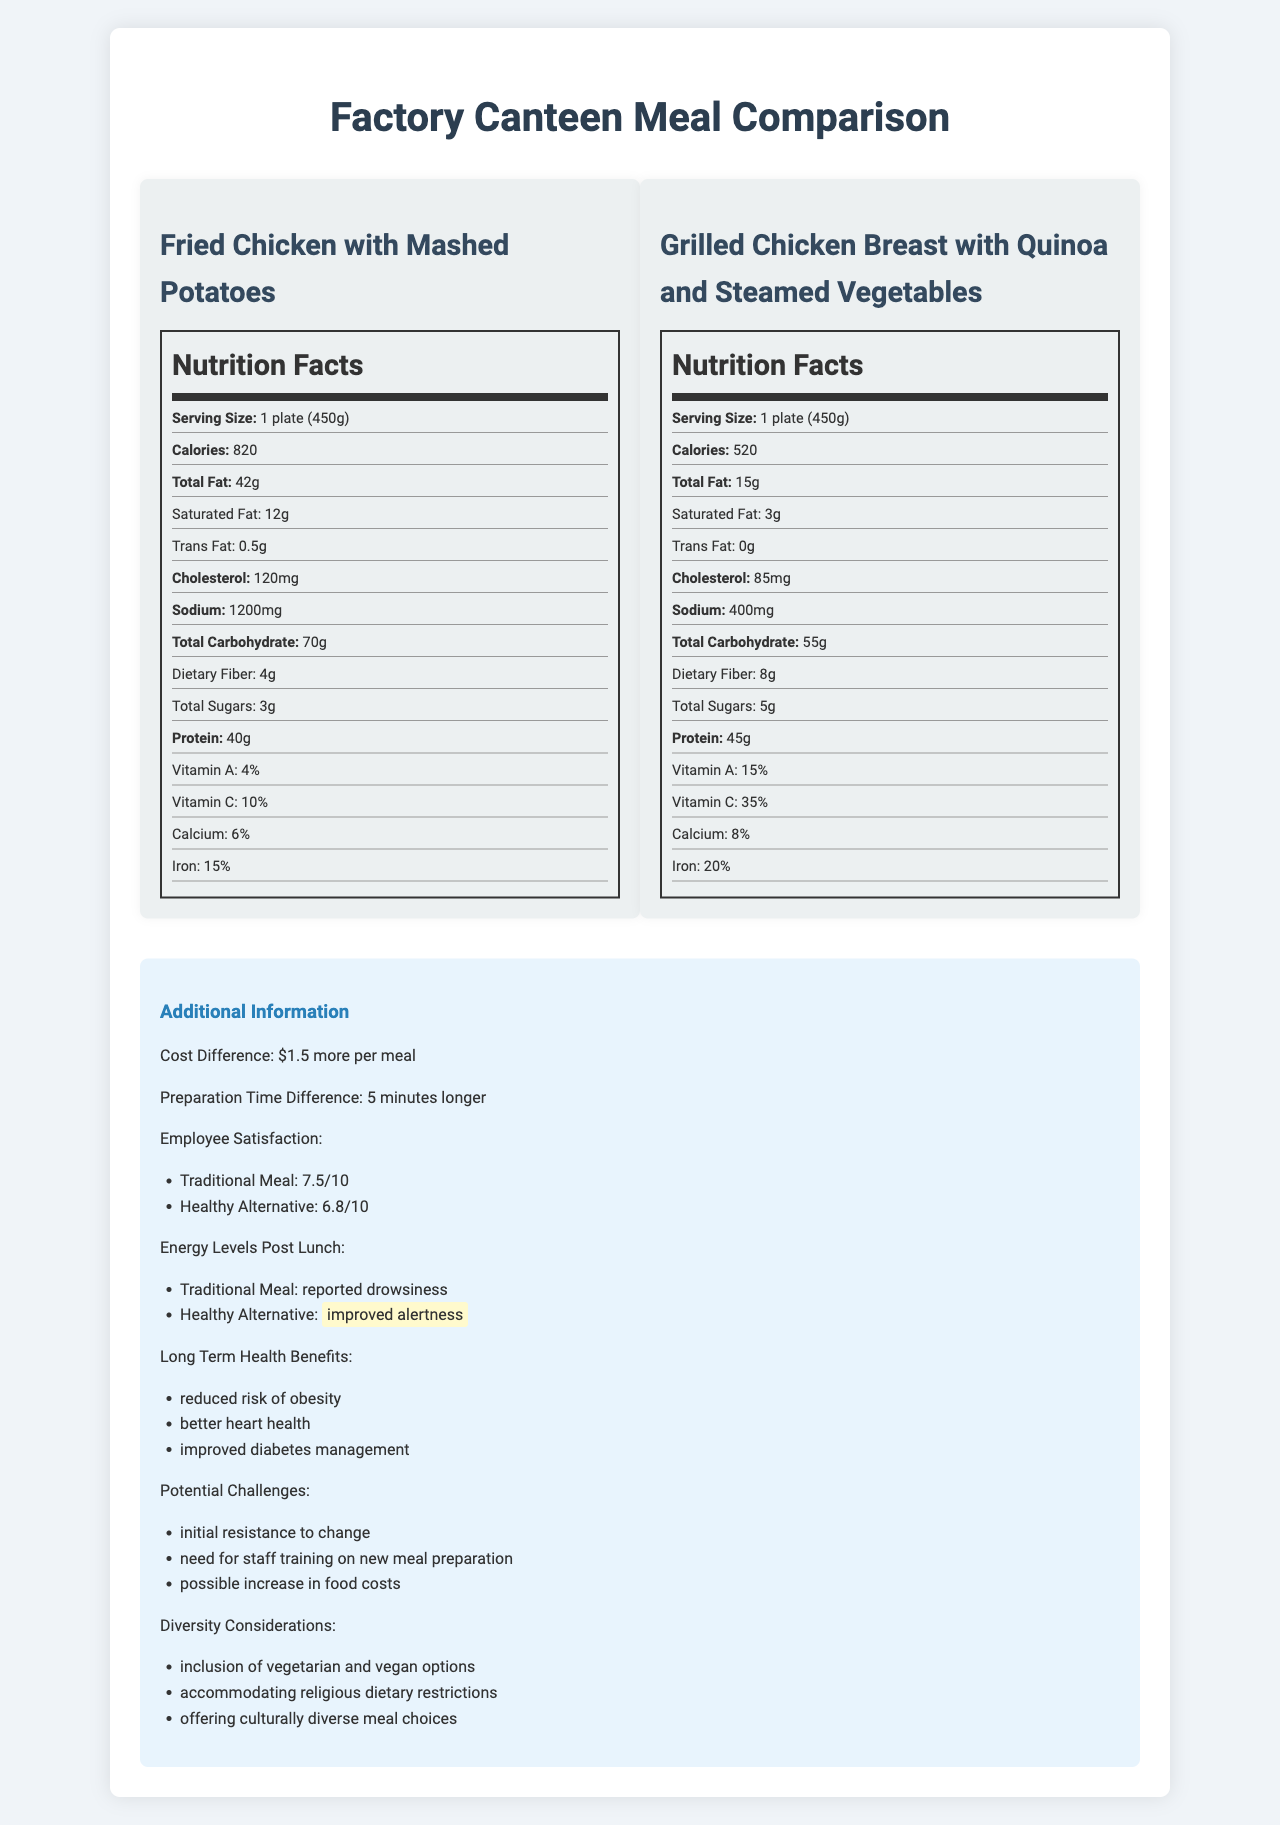What is the total fat content in the traditional meal? The total fat content in the traditional meal is stated as 42g in the nutrition facts section.
Answer: 42g Compare the calorie content of the traditional meal and the healthy alternative. The traditional meal has 820 calories, while the healthy alternative has 520 calories, as shown in their respective nutrition facts sections.
Answer: Traditional meal: 820 calories; Healthy alternative: 520 calories Which meal has a higher dietary fiber content? The healthy alternative has 8g of dietary fiber, while the traditional meal has 4g.
Answer: Healthy alternative What is the main difference in the cholesterol content between the two meals? The traditional meal has 120mg of cholesterol, while the healthy alternative has 85mg, making a difference of 35mg.
Answer: 35mg How much more sodium does the traditional meal have compared to the healthy alternative? The traditional meal has 1200mg of sodium, while the healthy alternative has 400mg, making a difference of 800mg.
Answer: 800mg Which meal has a higher protein content? A. Traditional Meal B. Healthy Alternative The healthy alternative has 45g of protein whereas the traditional meal has 40g.
Answer: B. Healthy Alternative What is the cost difference between the traditional meal and the healthy alternative? A. $1 B. $1.50 C. $2 D. $2.50 The additional information section states that the cost difference is $1.50 more per meal for the healthy alternative.
Answer: B. $1.50 Which meal is associated with improved alertness post-lunch? A. Traditional Meal B. Healthy Alternative The additional information section states that employees reported improved alertness after consuming the healthy alternative.
Answer: B. Healthy Alternative Is the energy level post-lunch reported as better for the traditional meal? The traditional meal is associated with reported drowsiness, whereas the healthy alternative is associated with improved alertness.
Answer: No Summarize the main idea of the document. This document provides a detailed comparison between a traditional meal and a healthier alternative, presenting nutritional differences, cost, preparation time, employee satisfaction ratings, energy levels post-lunch, and potential long-term health benefits and challenges.
Answer: The document compares the nutritional content and additional benefits of a traditional factory canteen meal (Fried Chicken with Mashed Potatoes) and a proposed healthier alternative (Grilled Chicken Breast with Quinoa and Steamed Vegetables). It includes detailed nutrition facts, cost and preparation time differences, employee satisfaction, and potential challenges and benefits of the healthier option. What specific type of cuisine is included in the diversity considerations? The document mentions the inclusion of culturally diverse meal choices in the diversity considerations, but it does not specify any particular type of cuisine.
Answer: Not enough information 